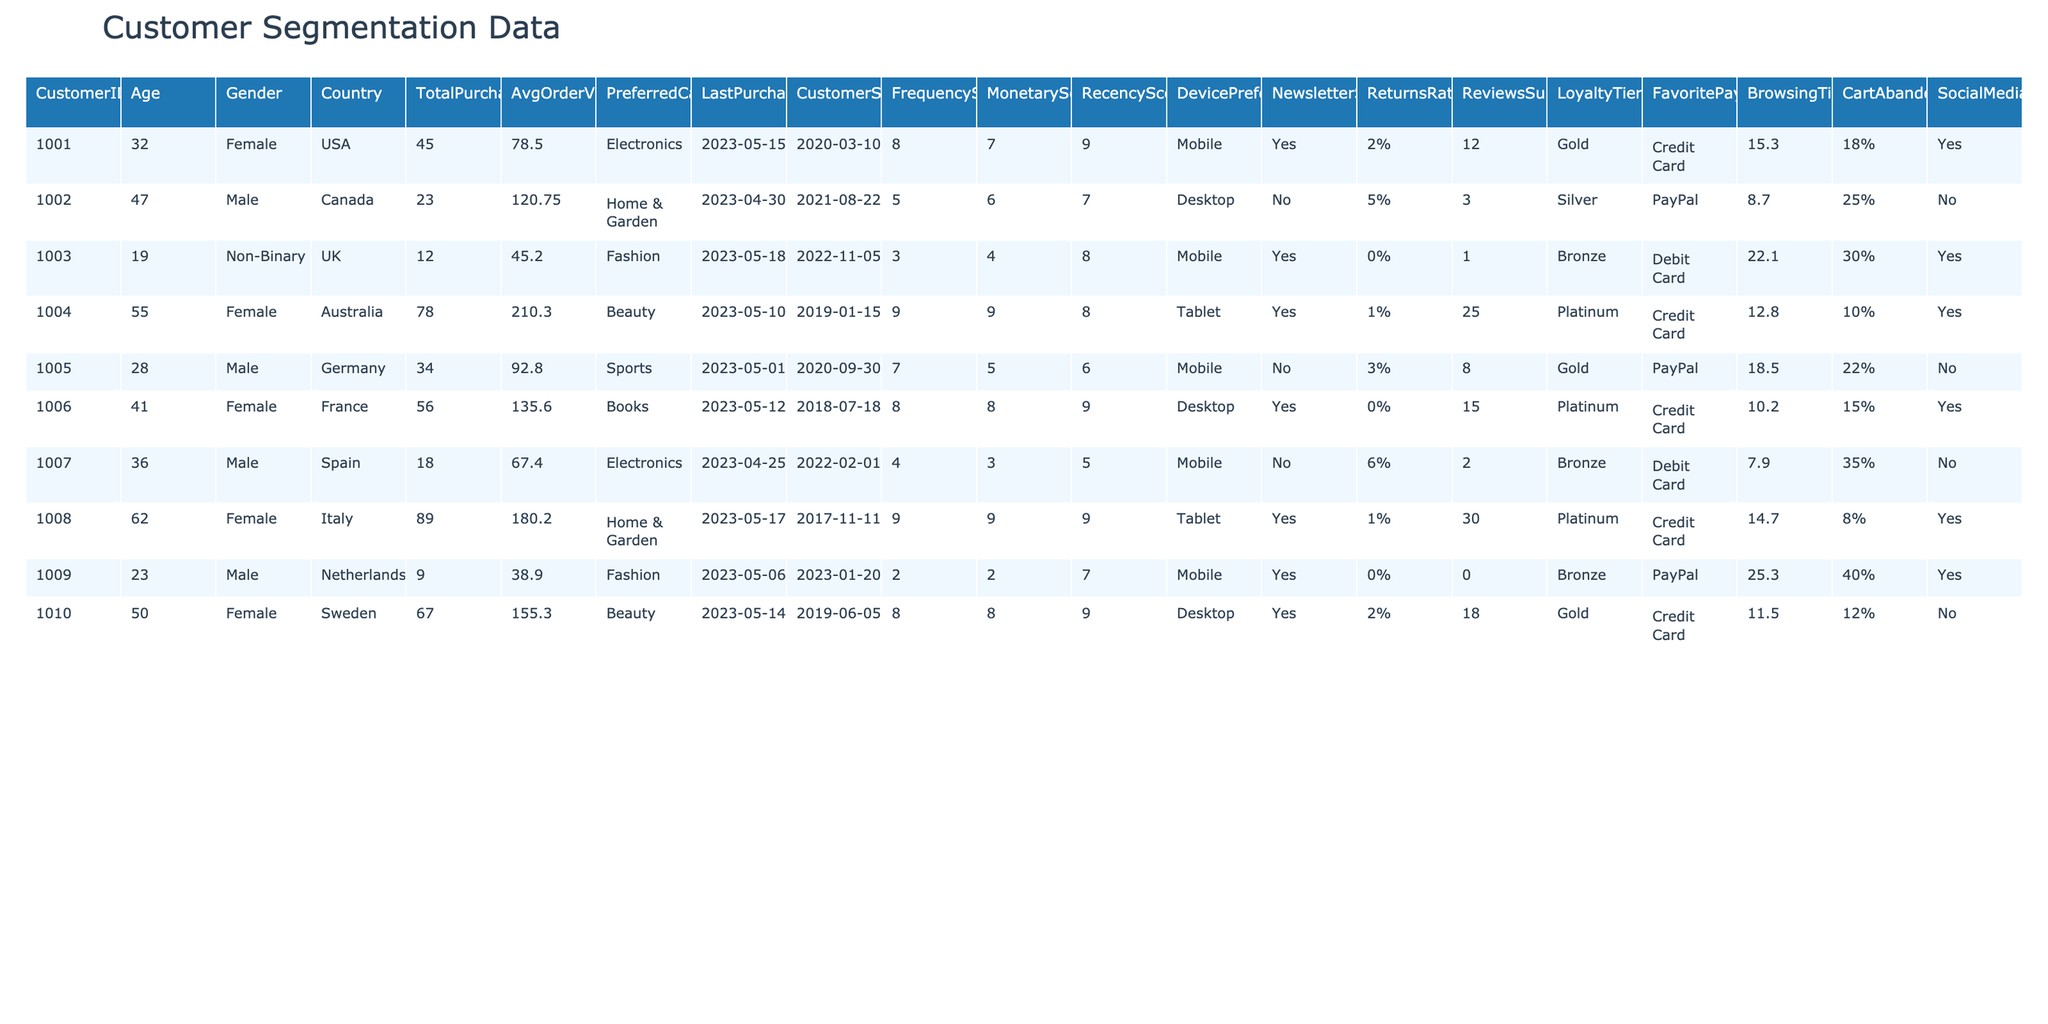What is the age of the customer with ID 1008? From the table, we can see the entry for CustomerID 1008, which shows that their age is 62.
Answer: 62 What is the total purchase value made by the customer from Germany? Looking at the row for the German customer (ID 1005), it shows their total purchases amount to 34.
Answer: 34 What is the preferred category of the customer with the highest total purchases? Reviewing the total purchases, customer ID 1004 has the highest value of 78, and their preferred category is Beauty.
Answer: Beauty Which device preference is most commonly used by customers in the dataset? By examining the DevicePreference column, we find that 5 customers prefer Mobile, 4 prefer Desktop, and 3 prefer Tablet. Therefore, Mobile is the most common device preference.
Answer: Mobile What is the average order value of all customers in the dataset? The average order value can be calculated by summing all AvgOrderValue values (78.50 + 120.75 + 45.20 + 210.30 + 92.80 + 135.60 + 67.40 + 180.20 + 38.90 + 155.30 = 1,111.75) and dividing by the number of customers (10). The average order value is thus 1,111.75/10 = 111.18.
Answer: 111.18 Which loyalty tier does a customer from the Netherlands belong to? Referring to the row for CustomerID 1009, we can see that the LoyaltyTier for this customer is Bronze.
Answer: Bronze Has the customer from France subscribed to the newsletter? Checking the entry for the customer with ID 1006, it indicates that this customer is subscribed to the newsletter, which is marked as 'Yes'.
Answer: Yes What is the difference in frequency score between the customer from Spain and the customer from Australia? The customer from Spain (ID 1007) has a FrequencyScore of 4, and the customer from Australia (ID 1004) has a FrequencyScore of 9. The difference is 9 - 4 = 5.
Answer: 5 What percentage of customers have a cart abandonment rate greater than 20%? Analyzing the CartAbandonmentRate column, we see that customers 1002, 1005, 1007, and 1009 have rates above 20%. This gives us 4 out of 10 customers, resulting in a percentage of 40%.
Answer: 40% Which country has the customer with the highest monetary score? Looking through the MonetaryScore column, the highest score is 9, which is shared by customers from both Australia (ID 1004) and Italy (ID 1008). Thus, the countries are Australia and Italy.
Answer: Australia and Italy What is the total returns rate for all customers? To find the total returns rate, we calculate by adding the return rates of each customer (0.02 + 0.05 + 0.00 + 0.01 + 0.03 + 0.00 + 0.06 + 0.01 + 0.00 + 0.02 = 0.20) and representing it as 20%.
Answer: 20% 